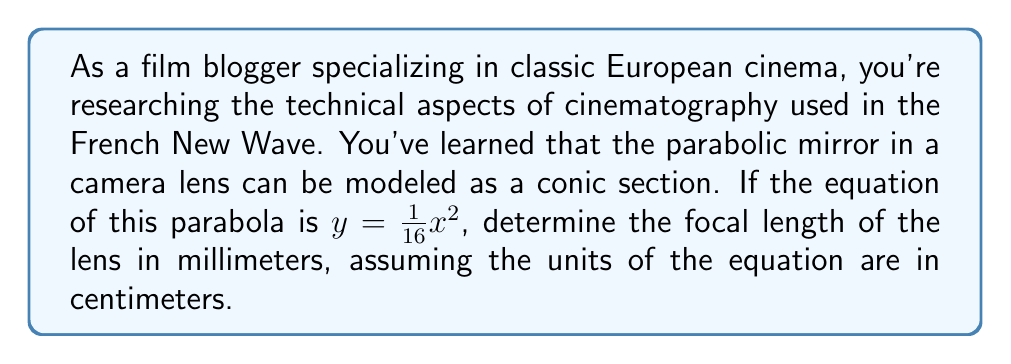Could you help me with this problem? To solve this problem, we'll follow these steps:

1) The general equation of a parabola with vertex at the origin and axis of symmetry along the y-axis is:

   $$y = \frac{1}{4p}x^2$$

   where $p$ is the distance from the vertex to the focus.

2) In our case, we have:

   $$y = \frac{1}{16}x^2$$

3) Comparing these equations, we can see that:

   $$\frac{1}{4p} = \frac{1}{16}$$

4) Solving for $p$:

   $$p = \frac{16}{4} = 4$$

5) This means the focal length is 4 centimeters.

6) To convert to millimeters, we multiply by 10:

   $$4 \text{ cm} \times 10 = 40 \text{ mm}$$

[asy]
import graph;
size(200);
real f(real x) {return x^2/16;}
draw(graph(f,-8,8));
draw((-8,0)--(8,0),arrow=Arrow);
draw((0,-1)--(0,4),arrow=Arrow);
label("x",(-8,0),SW);
label("y",(0,4),NE);
dot((0,4));
label("Focus",(0,4),E);
[/asy]
Answer: The focal length of the lens is 40 mm. 